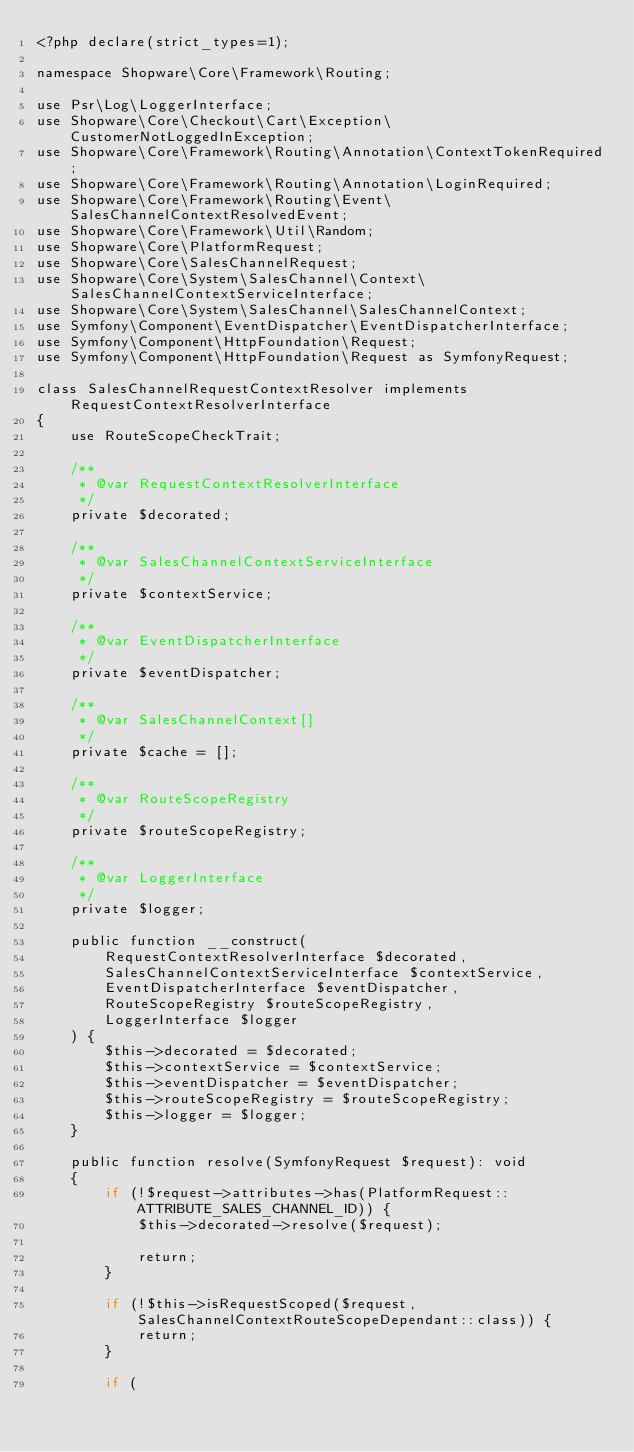<code> <loc_0><loc_0><loc_500><loc_500><_PHP_><?php declare(strict_types=1);

namespace Shopware\Core\Framework\Routing;

use Psr\Log\LoggerInterface;
use Shopware\Core\Checkout\Cart\Exception\CustomerNotLoggedInException;
use Shopware\Core\Framework\Routing\Annotation\ContextTokenRequired;
use Shopware\Core\Framework\Routing\Annotation\LoginRequired;
use Shopware\Core\Framework\Routing\Event\SalesChannelContextResolvedEvent;
use Shopware\Core\Framework\Util\Random;
use Shopware\Core\PlatformRequest;
use Shopware\Core\SalesChannelRequest;
use Shopware\Core\System\SalesChannel\Context\SalesChannelContextServiceInterface;
use Shopware\Core\System\SalesChannel\SalesChannelContext;
use Symfony\Component\EventDispatcher\EventDispatcherInterface;
use Symfony\Component\HttpFoundation\Request;
use Symfony\Component\HttpFoundation\Request as SymfonyRequest;

class SalesChannelRequestContextResolver implements RequestContextResolverInterface
{
    use RouteScopeCheckTrait;

    /**
     * @var RequestContextResolverInterface
     */
    private $decorated;

    /**
     * @var SalesChannelContextServiceInterface
     */
    private $contextService;

    /**
     * @var EventDispatcherInterface
     */
    private $eventDispatcher;

    /**
     * @var SalesChannelContext[]
     */
    private $cache = [];

    /**
     * @var RouteScopeRegistry
     */
    private $routeScopeRegistry;

    /**
     * @var LoggerInterface
     */
    private $logger;

    public function __construct(
        RequestContextResolverInterface $decorated,
        SalesChannelContextServiceInterface $contextService,
        EventDispatcherInterface $eventDispatcher,
        RouteScopeRegistry $routeScopeRegistry,
        LoggerInterface $logger
    ) {
        $this->decorated = $decorated;
        $this->contextService = $contextService;
        $this->eventDispatcher = $eventDispatcher;
        $this->routeScopeRegistry = $routeScopeRegistry;
        $this->logger = $logger;
    }

    public function resolve(SymfonyRequest $request): void
    {
        if (!$request->attributes->has(PlatformRequest::ATTRIBUTE_SALES_CHANNEL_ID)) {
            $this->decorated->resolve($request);

            return;
        }

        if (!$this->isRequestScoped($request, SalesChannelContextRouteScopeDependant::class)) {
            return;
        }

        if (</code> 